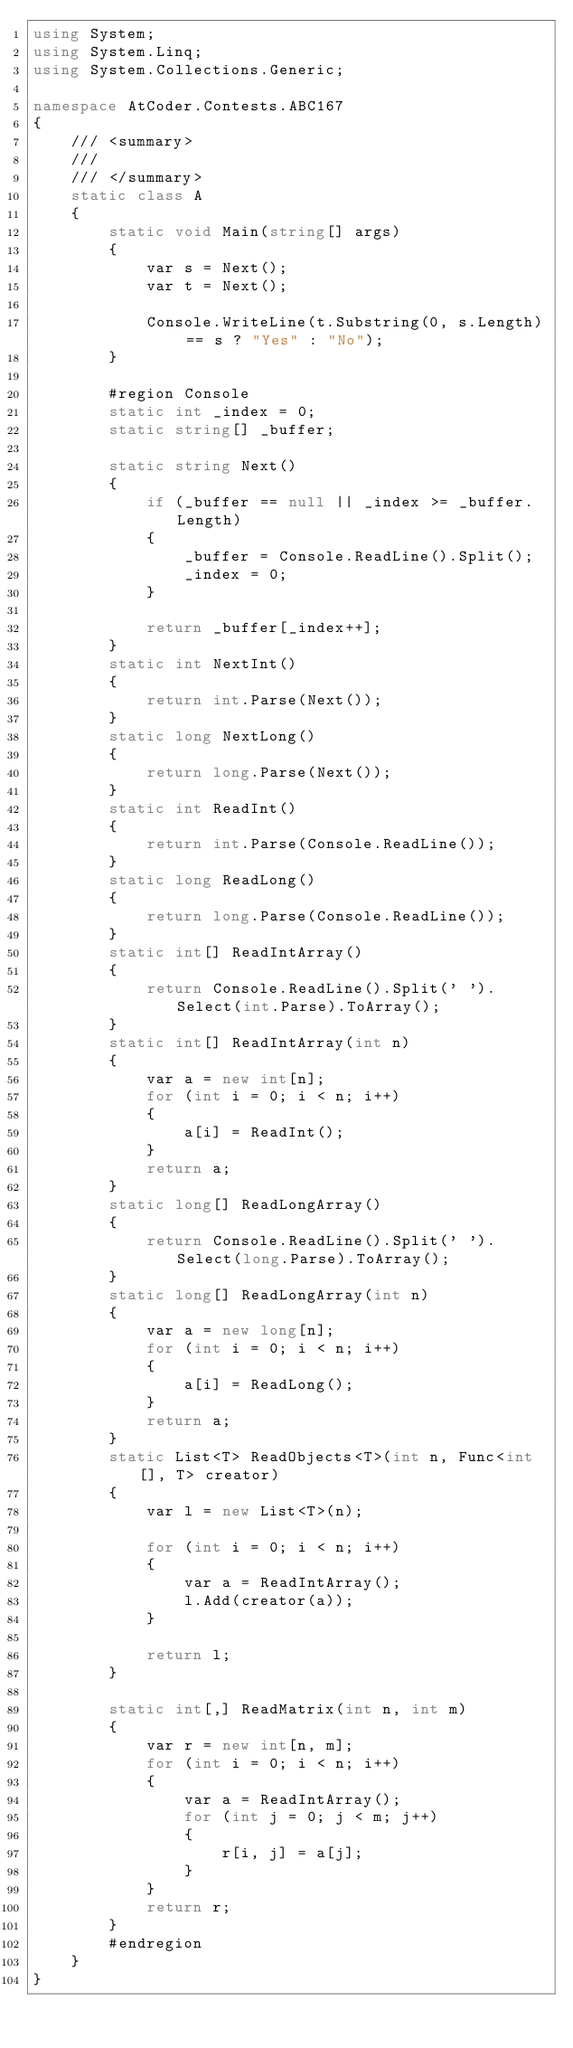<code> <loc_0><loc_0><loc_500><loc_500><_C#_>using System;
using System.Linq;
using System.Collections.Generic;

namespace AtCoder.Contests.ABC167
{
    /// <summary>
    /// 
    /// </summary>
    static class A
    {
        static void Main(string[] args)
        {
            var s = Next();
            var t = Next();

            Console.WriteLine(t.Substring(0, s.Length) == s ? "Yes" : "No");
        }

        #region Console
        static int _index = 0;
        static string[] _buffer;

        static string Next()
        {
            if (_buffer == null || _index >= _buffer.Length)
            {
                _buffer = Console.ReadLine().Split();
                _index = 0;
            }

            return _buffer[_index++];
        }
        static int NextInt()
        {
            return int.Parse(Next());
        }
        static long NextLong()
        {
            return long.Parse(Next());
        }
        static int ReadInt()
        {
            return int.Parse(Console.ReadLine());
        }
        static long ReadLong()
        {
            return long.Parse(Console.ReadLine());
        }
        static int[] ReadIntArray()
        {
            return Console.ReadLine().Split(' ').Select(int.Parse).ToArray();
        }
        static int[] ReadIntArray(int n)
        {
            var a = new int[n];
            for (int i = 0; i < n; i++)
            {
                a[i] = ReadInt();
            }
            return a;
        }
        static long[] ReadLongArray()
        {
            return Console.ReadLine().Split(' ').Select(long.Parse).ToArray();
        }
        static long[] ReadLongArray(int n)
        {
            var a = new long[n];
            for (int i = 0; i < n; i++)
            {
                a[i] = ReadLong();
            }
            return a;
        }
        static List<T> ReadObjects<T>(int n, Func<int[], T> creator)
        {
            var l = new List<T>(n);

            for (int i = 0; i < n; i++)
            {
                var a = ReadIntArray();
                l.Add(creator(a));
            }

            return l;
        }

        static int[,] ReadMatrix(int n, int m)
        {
            var r = new int[n, m];
            for (int i = 0; i < n; i++)
            {
                var a = ReadIntArray();
                for (int j = 0; j < m; j++)
                {
                    r[i, j] = a[j];
                }
            }
            return r;
        }
        #endregion
    }
}
</code> 